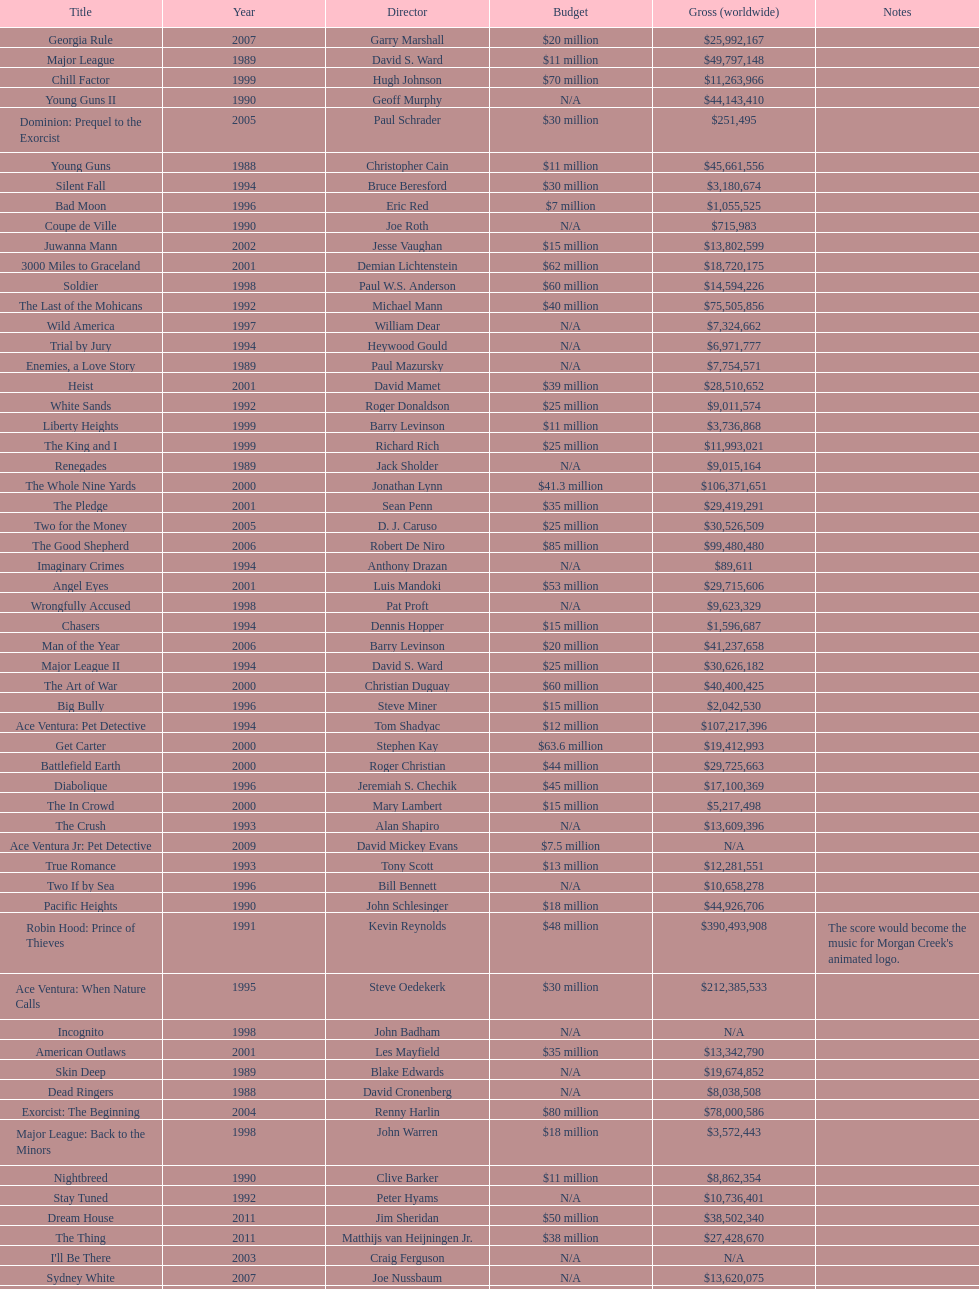Was the budget for young guns more or less than freejack's budget? Less. 